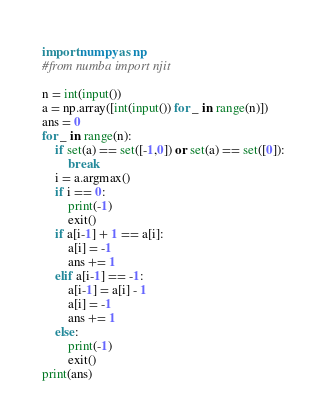<code> <loc_0><loc_0><loc_500><loc_500><_Python_>import numpy as np
#from numba import njit

n = int(input())
a = np.array([int(input()) for _ in range(n)])
ans = 0
for _ in range(n):
    if set(a) == set([-1,0]) or set(a) == set([0]):
        break
    i = a.argmax()
    if i == 0:
        print(-1)
        exit()
    if a[i-1] + 1 == a[i]:
        a[i] = -1
        ans += 1
    elif a[i-1] == -1:
        a[i-1] = a[i] - 1
        a[i] = -1
        ans += 1
    else:
        print(-1)
        exit()
print(ans)</code> 